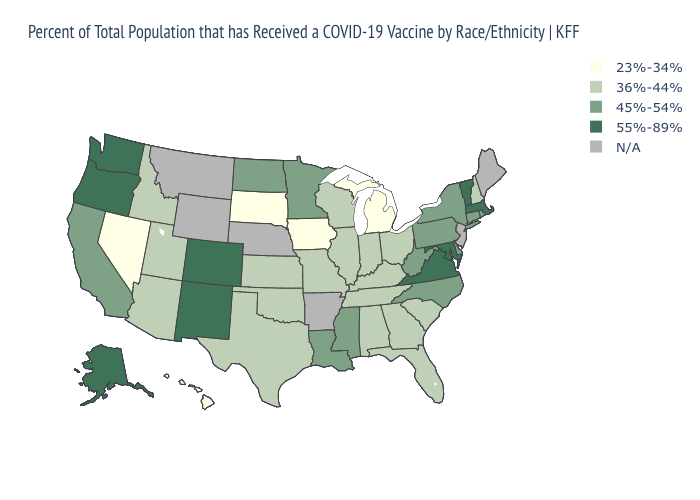What is the value of Indiana?
Give a very brief answer. 36%-44%. What is the value of West Virginia?
Keep it brief. 45%-54%. Does Hawaii have the lowest value in the USA?
Concise answer only. Yes. What is the value of Wisconsin?
Write a very short answer. 36%-44%. Among the states that border Nevada , does California have the highest value?
Give a very brief answer. No. Which states have the highest value in the USA?
Quick response, please. Alaska, Colorado, Maryland, Massachusetts, New Mexico, Oregon, Vermont, Virginia, Washington. How many symbols are there in the legend?
Write a very short answer. 5. Does Washington have the highest value in the USA?
Give a very brief answer. Yes. What is the value of Vermont?
Short answer required. 55%-89%. What is the value of Nevada?
Answer briefly. 23%-34%. What is the lowest value in the West?
Give a very brief answer. 23%-34%. Name the states that have a value in the range 36%-44%?
Short answer required. Alabama, Arizona, Florida, Georgia, Idaho, Illinois, Indiana, Kansas, Kentucky, Missouri, New Hampshire, Ohio, Oklahoma, South Carolina, Tennessee, Texas, Utah, Wisconsin. Name the states that have a value in the range 45%-54%?
Keep it brief. California, Connecticut, Delaware, Louisiana, Minnesota, Mississippi, New York, North Carolina, North Dakota, Pennsylvania, Rhode Island, West Virginia. Name the states that have a value in the range 55%-89%?
Be succinct. Alaska, Colorado, Maryland, Massachusetts, New Mexico, Oregon, Vermont, Virginia, Washington. 